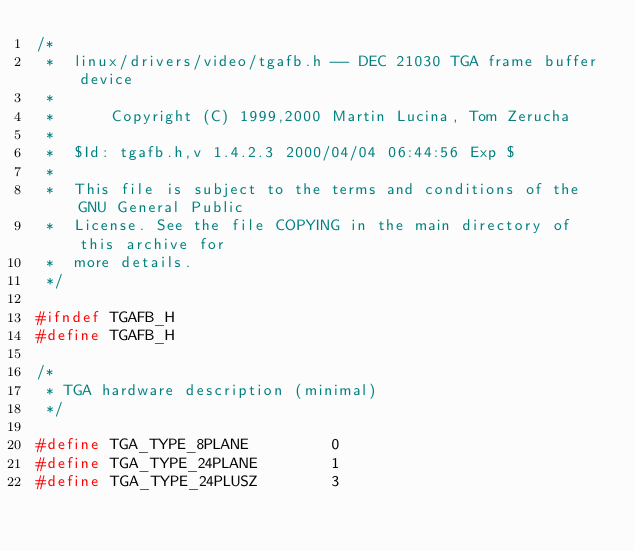Convert code to text. <code><loc_0><loc_0><loc_500><loc_500><_C_>/*
 *  linux/drivers/video/tgafb.h -- DEC 21030 TGA frame buffer device
 *
 *  	Copyright (C) 1999,2000 Martin Lucina, Tom Zerucha
 *  
 *  $Id: tgafb.h,v 1.4.2.3 2000/04/04 06:44:56 Exp $
 *
 *  This file is subject to the terms and conditions of the GNU General Public
 *  License. See the file COPYING in the main directory of this archive for
 *  more details.
 */

#ifndef TGAFB_H
#define TGAFB_H

/*
 * TGA hardware description (minimal)
 */

#define TGA_TYPE_8PLANE			0
#define TGA_TYPE_24PLANE		1
#define TGA_TYPE_24PLUSZ		3
</code> 